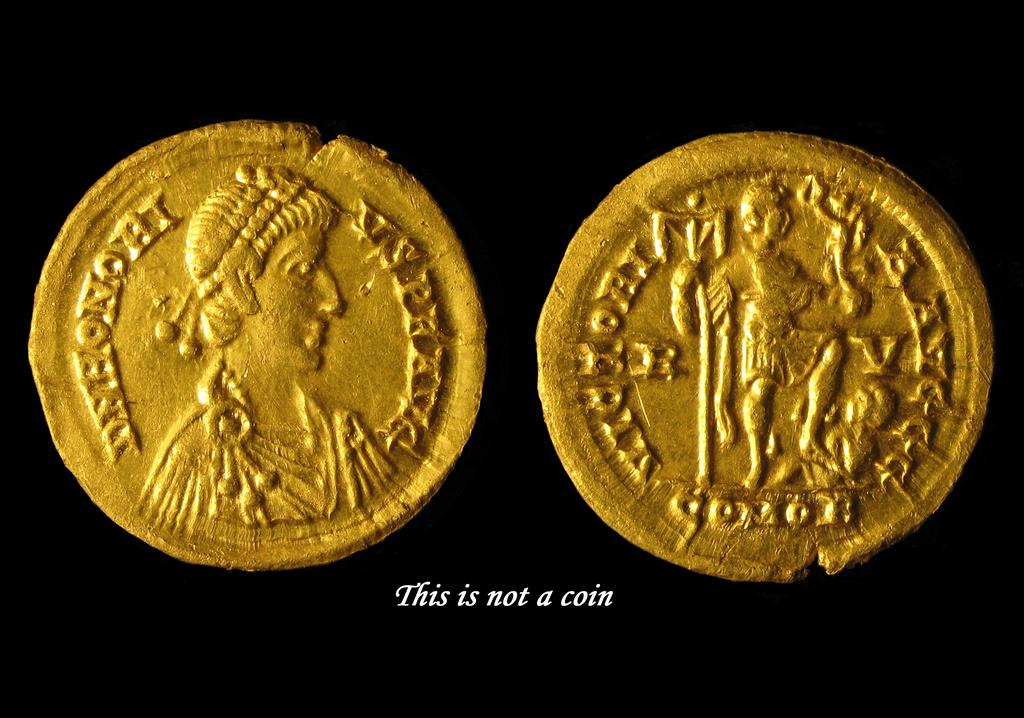Are these coins?
Offer a terse response. No. 